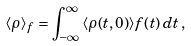Convert formula to latex. <formula><loc_0><loc_0><loc_500><loc_500>\langle \rho \rangle _ { f } = \int ^ { \infty } _ { - \infty } \, \langle \rho ( t , { 0 } ) \rangle f ( t ) \, d t \, ,</formula> 